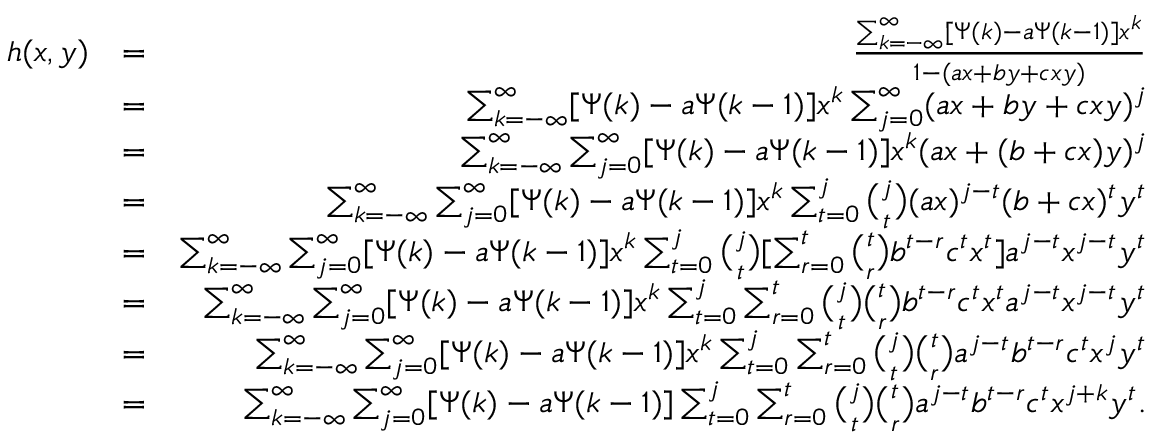Convert formula to latex. <formula><loc_0><loc_0><loc_500><loc_500>\begin{array} { r l r } { h ( x , y ) } & { = } & { \frac { \sum _ { k = - \infty } ^ { \infty } [ \Psi ( k ) - a \Psi ( k - 1 ) ] x ^ { k } } { 1 - ( a x + b y + c x y ) } } \\ & { = } & { \sum _ { k = - \infty } ^ { \infty } [ \Psi ( k ) - a \Psi ( k - 1 ) ] x ^ { k } \sum _ { j = 0 } ^ { \infty } ( a x + b y + c x y ) ^ { j } } \\ & { = } & { \sum _ { k = - \infty } ^ { \infty } \sum _ { j = 0 } ^ { \infty } [ \Psi ( k ) - a \Psi ( k - 1 ) ] x ^ { k } ( a x + ( b + c x ) y ) ^ { j } } \\ & { = } & { \sum _ { k = - \infty } ^ { \infty } \sum _ { j = 0 } ^ { \infty } [ \Psi ( k ) - a \Psi ( k - 1 ) ] x ^ { k } \sum _ { t = 0 } ^ { j } \binom { j } { t } ( a x ) ^ { j - t } ( b + c x ) ^ { t } y ^ { t } } \\ & { = } & { \sum _ { k = - \infty } ^ { \infty } \sum _ { j = 0 } ^ { \infty } [ \Psi ( k ) - a \Psi ( k - 1 ) ] x ^ { k } \sum _ { t = 0 } ^ { j } \binom { j } { t } [ \sum _ { r = 0 } ^ { t } \binom { t } { r } b ^ { t - r } c ^ { t } x ^ { t } ] a ^ { j - t } x ^ { j - t } y ^ { t } } \\ & { = } & { \sum _ { k = - \infty } ^ { \infty } \sum _ { j = 0 } ^ { \infty } [ \Psi ( k ) - a \Psi ( k - 1 ) ] x ^ { k } \sum _ { t = 0 } ^ { j } \sum _ { r = 0 } ^ { t } \binom { j } { t } \binom { t } { r } b ^ { t - r } c ^ { t } x ^ { t } a ^ { j - t } x ^ { j - t } y ^ { t } } \\ & { = } & { \sum _ { k = - \infty } ^ { \infty } \sum _ { j = 0 } ^ { \infty } [ \Psi ( k ) - a \Psi ( k - 1 ) ] x ^ { k } \sum _ { t = 0 } ^ { j } \sum _ { r = 0 } ^ { t } \binom { j } { t } \binom { t } { r } a ^ { j - t } b ^ { t - r } c ^ { t } x ^ { j } y ^ { t } } \\ & { = } & { \sum _ { k = - \infty } ^ { \infty } \sum _ { j = 0 } ^ { \infty } [ \Psi ( k ) - a \Psi ( k - 1 ) ] \sum _ { t = 0 } ^ { j } \sum _ { r = 0 } ^ { t } \binom { j } { t } \binom { t } { r } a ^ { j - t } b ^ { t - r } c ^ { t } x ^ { j + k } y ^ { t } . } \end{array}</formula> 